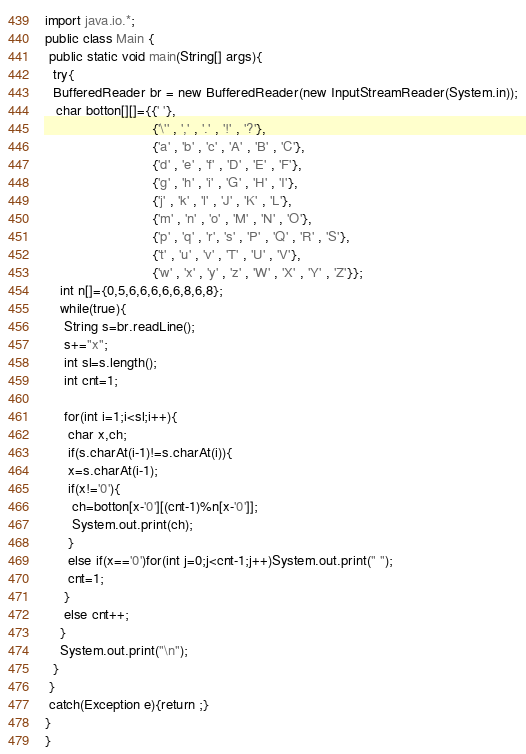<code> <loc_0><loc_0><loc_500><loc_500><_Java_>import java.io.*;
public class Main {
 public static void main(String[] args){
  try{
  BufferedReader br = new BufferedReader(new InputStreamReader(System.in));
   char botton[][]={{' '},
                            {'\'' , ',' , '.' , '!' , '?'},
                            {'a' , 'b' , 'c' , 'A' , 'B' , 'C'},
                            {'d' , 'e' , 'f' , 'D' , 'E' , 'F'},
                            {'g' , 'h' , 'i' , 'G' , 'H' , 'I'},
                            {'j' , 'k' , 'l' , 'J' , 'K' , 'L'},
                            {'m' , 'n' , 'o' , 'M' , 'N' , 'O'},
                            {'p' , 'q' , 'r', 's' , 'P' , 'Q' , 'R' , 'S'},
                            {'t' , 'u' , 'v' , 'T' , 'U' , 'V'},
                            {'w' , 'x' , 'y' , 'z' , 'W' , 'X' , 'Y' , 'Z'}};
    int n[]={0,5,6,6,6,6,6,8,6,8};
    while(true){
     String s=br.readLine();
     s+="x";
     int sl=s.length();
     int cnt=1;
     
     for(int i=1;i<sl;i++){
      char x,ch;
      if(s.charAt(i-1)!=s.charAt(i)){
      x=s.charAt(i-1);
      if(x!='0'){
       ch=botton[x-'0'][(cnt-1)%n[x-'0']];
       System.out.print(ch);
      }
      else if(x=='0')for(int j=0;j<cnt-1;j++)System.out.print(" ");
      cnt=1;
     }
     else cnt++;
    }
    System.out.print("\n");
  }
 }
 catch(Exception e){return ;}
}
}

</code> 